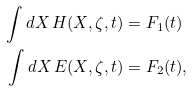<formula> <loc_0><loc_0><loc_500><loc_500>\int d X \, H ( X , \zeta , t ) & = F _ { 1 } ( t ) \\ \int d X \, E ( X , \zeta , t ) & = F _ { 2 } ( t ) ,</formula> 